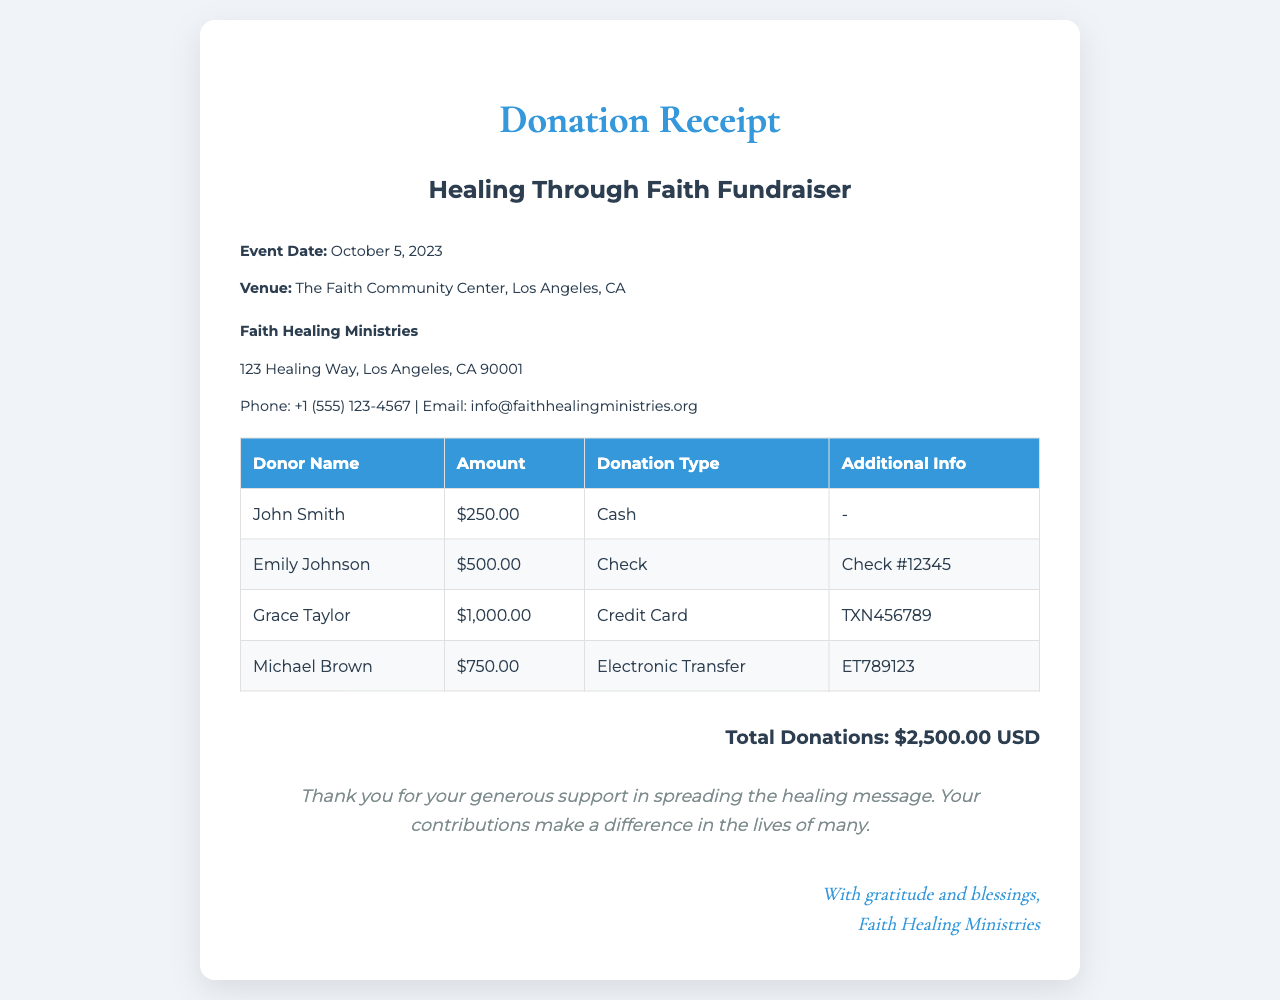what is the event date? The event date is listed in the document under the event details section.
Answer: October 5, 2023 where was the fundraising event held? The venue for the fundraising event is specified in the document.
Answer: The Faith Community Center, Los Angeles, CA who is the ministry receiving donations? The name of the ministry is clearly stated in the document.
Answer: Faith Healing Ministries what is the total amount of donations received? The total donations are summarized at the end of the donation table.
Answer: $2,500.00 USD how much did Grace Taylor donate? The donation amount is detailed in the donations table.
Answer: $1,000.00 which payment method did Michael Brown use? The donation type is provided in the donations table for each donor.
Answer: Electronic Transfer who made the cash donation? The donor’s name is listed in the donations table along with their contributions.
Answer: John Smith what is the check number for Emily Johnson's donation? The additional info for each donor's contribution is included in the donations table.
Answer: Check #12345 what message is included for donors? The thank-you message is found at the bottom of the receipt.
Answer: Thank you for your generous support in spreading the healing message 